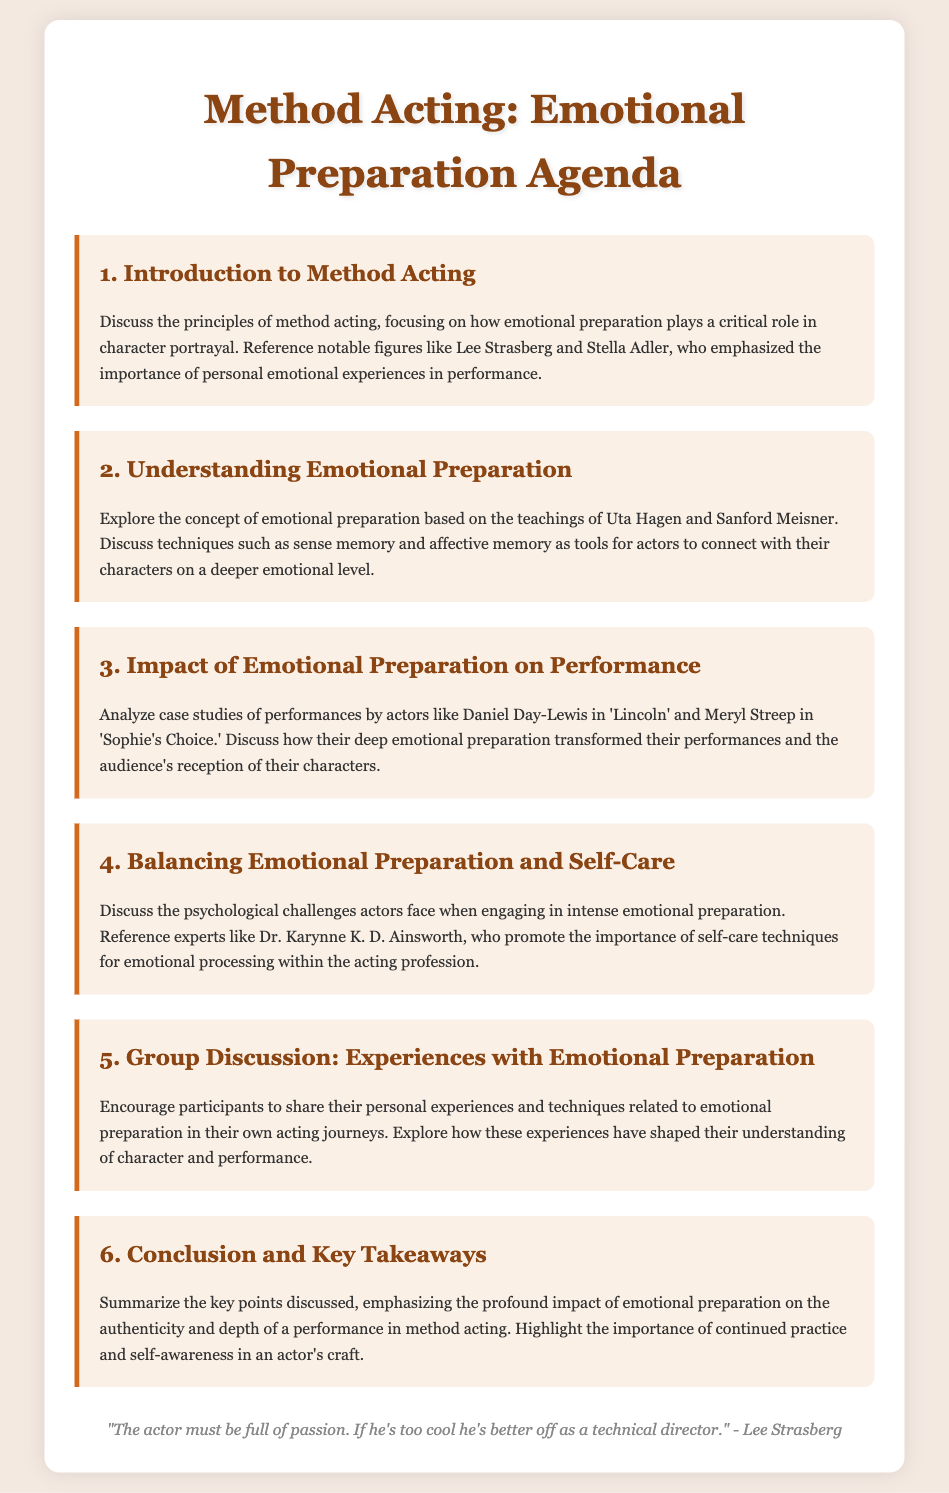What is the title of the agenda? The title of the agenda is mentioned at the top of the document.
Answer: Method Acting: Emotional Preparation Agenda Who are the notable figures referenced in the introduction? The introduction mentions notable figures important to method acting.
Answer: Lee Strasberg and Stella Adler Which techniques are discussed in relation to emotional preparation? The emotional preparation section details techniques taught by Uta Hagen and Sanford Meisner.
Answer: Sense memory and affective memory Which actors are analyzed for their performances in the impact section? The impact section provides examples of specific actors who exemplified emotional preparation.
Answer: Daniel Day-Lewis and Meryl Streep What psychological challenges are discussed in relation to emotional preparation? The section on balancing emotional preparation addresses psychological challenges faced by actors.
Answer: Intense emotional preparation What is one expert mentioned who promotes self-care techniques? The section on balancing emotional preparation references an expert discussing self-care.
Answer: Dr. Karynne K. D. Ainsworth What is the main focus of the group discussion? The group discussion section encourages sharing personal experiences related to emotional preparation.
Answer: Experiences with emotional preparation What is emphasized in the conclusion regarding actor's craft? The conclusion summarizes key points and discusses ongoing responsibilities for actors.
Answer: Continued practice and self-awareness 